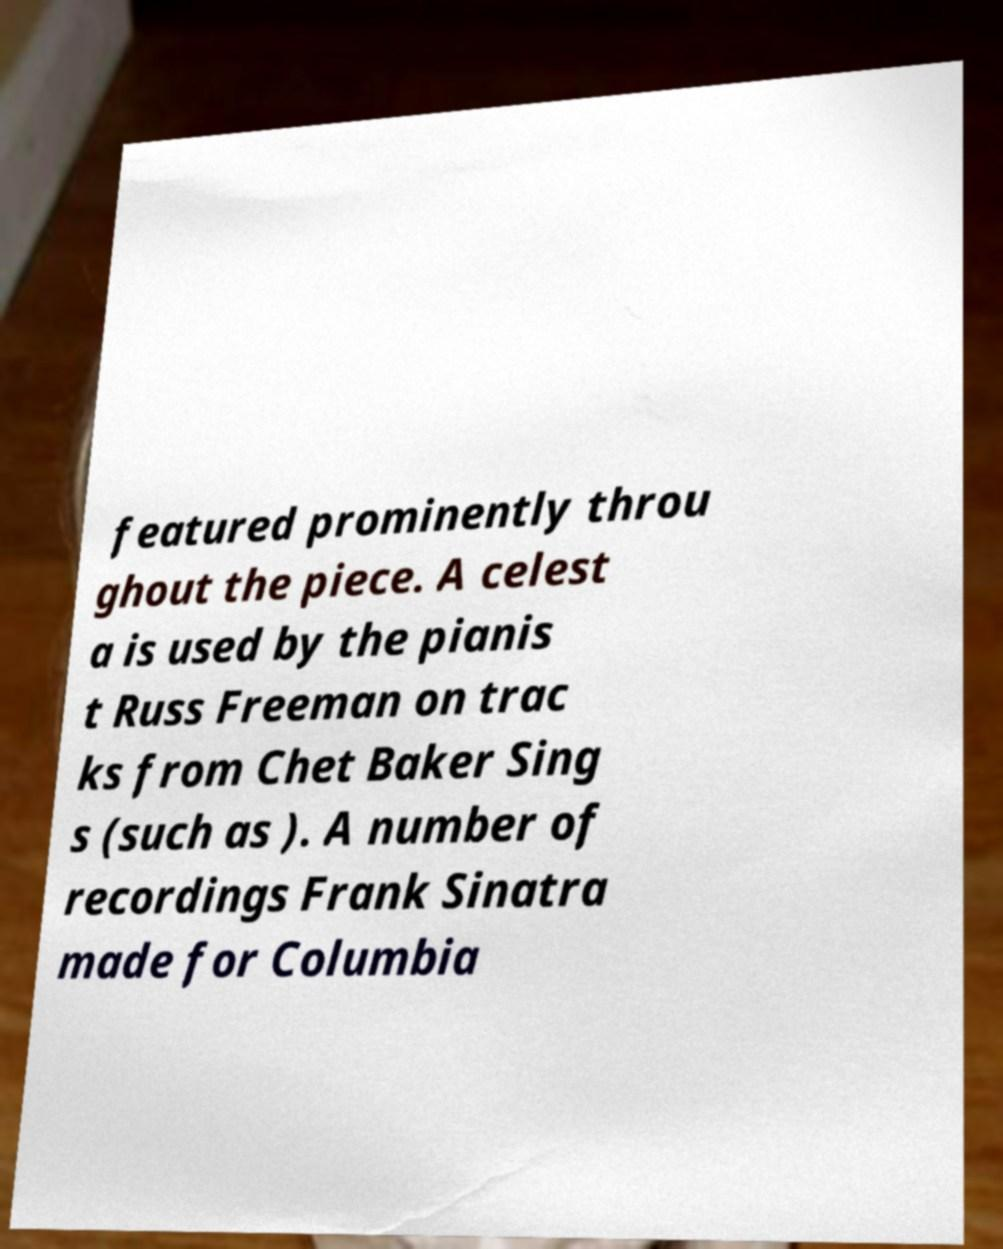Could you assist in decoding the text presented in this image and type it out clearly? featured prominently throu ghout the piece. A celest a is used by the pianis t Russ Freeman on trac ks from Chet Baker Sing s (such as ). A number of recordings Frank Sinatra made for Columbia 